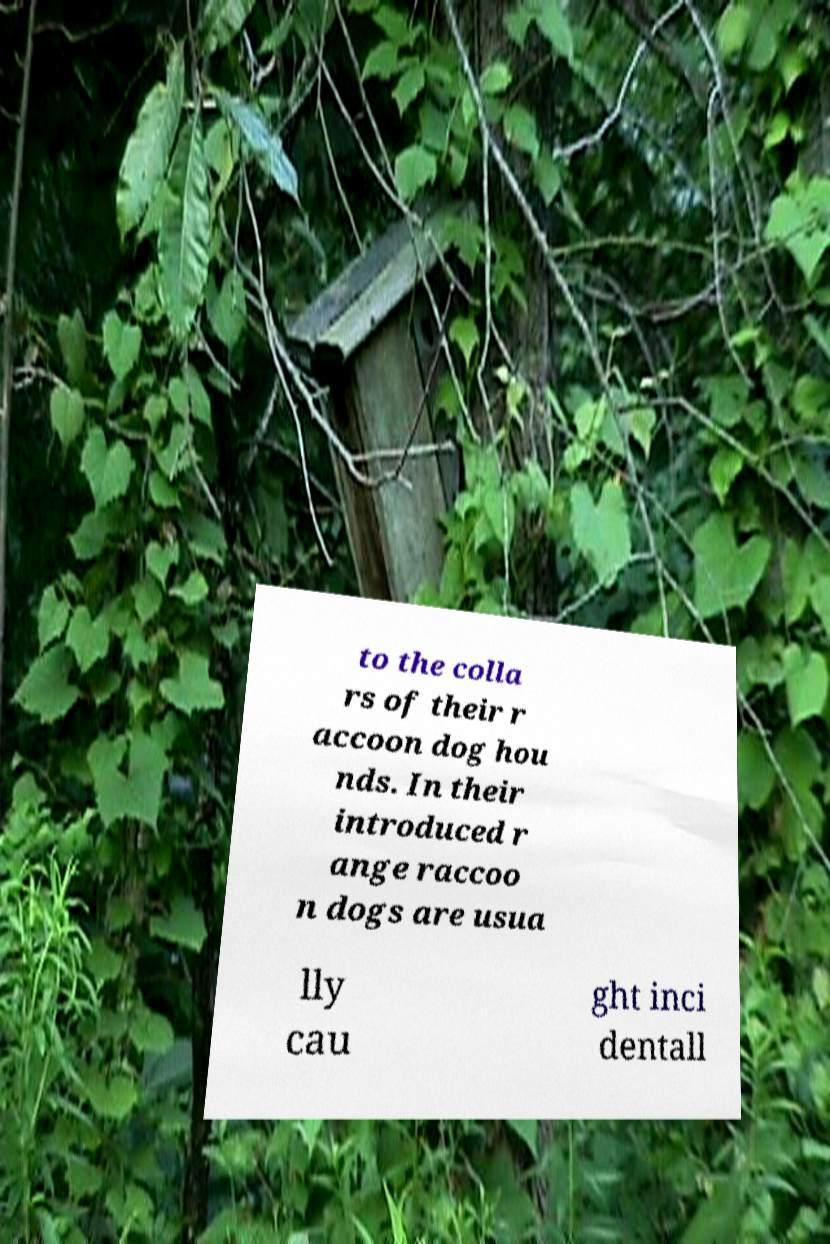Please identify and transcribe the text found in this image. to the colla rs of their r accoon dog hou nds. In their introduced r ange raccoo n dogs are usua lly cau ght inci dentall 